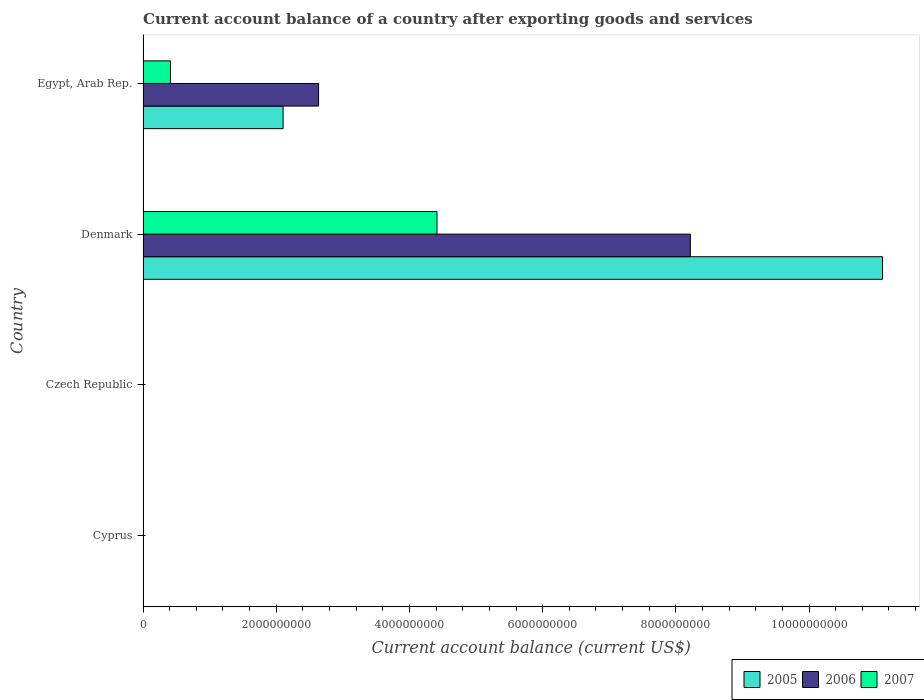How many different coloured bars are there?
Keep it short and to the point. 3. Are the number of bars on each tick of the Y-axis equal?
Your answer should be very brief. No. How many bars are there on the 4th tick from the top?
Give a very brief answer. 0. What is the label of the 4th group of bars from the top?
Your answer should be compact. Cyprus. What is the account balance in 2005 in Egypt, Arab Rep.?
Your answer should be very brief. 2.10e+09. Across all countries, what is the maximum account balance in 2005?
Your answer should be very brief. 1.11e+1. Across all countries, what is the minimum account balance in 2007?
Your answer should be very brief. 0. In which country was the account balance in 2007 maximum?
Make the answer very short. Denmark. What is the total account balance in 2007 in the graph?
Offer a terse response. 4.83e+09. What is the difference between the account balance in 2005 in Denmark and that in Egypt, Arab Rep.?
Give a very brief answer. 9.00e+09. What is the difference between the account balance in 2006 in Czech Republic and the account balance in 2005 in Egypt, Arab Rep.?
Keep it short and to the point. -2.10e+09. What is the average account balance in 2007 per country?
Your response must be concise. 1.21e+09. What is the difference between the account balance in 2005 and account balance in 2007 in Denmark?
Ensure brevity in your answer.  6.69e+09. In how many countries, is the account balance in 2005 greater than 7200000000 US$?
Offer a very short reply. 1. What is the ratio of the account balance in 2006 in Denmark to that in Egypt, Arab Rep.?
Your answer should be very brief. 3.12. What is the difference between the highest and the lowest account balance in 2005?
Your response must be concise. 1.11e+1. Is the sum of the account balance in 2007 in Denmark and Egypt, Arab Rep. greater than the maximum account balance in 2005 across all countries?
Make the answer very short. No. Are all the bars in the graph horizontal?
Make the answer very short. Yes. What is the difference between two consecutive major ticks on the X-axis?
Give a very brief answer. 2.00e+09. Are the values on the major ticks of X-axis written in scientific E-notation?
Give a very brief answer. No. Does the graph contain any zero values?
Make the answer very short. Yes. What is the title of the graph?
Make the answer very short. Current account balance of a country after exporting goods and services. Does "1966" appear as one of the legend labels in the graph?
Keep it short and to the point. No. What is the label or title of the X-axis?
Keep it short and to the point. Current account balance (current US$). What is the Current account balance (current US$) in 2006 in Cyprus?
Give a very brief answer. 0. What is the Current account balance (current US$) of 2007 in Cyprus?
Provide a short and direct response. 0. What is the Current account balance (current US$) in 2005 in Czech Republic?
Provide a short and direct response. 0. What is the Current account balance (current US$) of 2005 in Denmark?
Your answer should be compact. 1.11e+1. What is the Current account balance (current US$) of 2006 in Denmark?
Your answer should be compact. 8.22e+09. What is the Current account balance (current US$) of 2007 in Denmark?
Give a very brief answer. 4.41e+09. What is the Current account balance (current US$) in 2005 in Egypt, Arab Rep.?
Provide a succinct answer. 2.10e+09. What is the Current account balance (current US$) of 2006 in Egypt, Arab Rep.?
Your answer should be compact. 2.64e+09. What is the Current account balance (current US$) in 2007 in Egypt, Arab Rep.?
Offer a very short reply. 4.12e+08. Across all countries, what is the maximum Current account balance (current US$) of 2005?
Your answer should be very brief. 1.11e+1. Across all countries, what is the maximum Current account balance (current US$) in 2006?
Offer a terse response. 8.22e+09. Across all countries, what is the maximum Current account balance (current US$) of 2007?
Keep it short and to the point. 4.41e+09. Across all countries, what is the minimum Current account balance (current US$) of 2006?
Ensure brevity in your answer.  0. Across all countries, what is the minimum Current account balance (current US$) in 2007?
Provide a short and direct response. 0. What is the total Current account balance (current US$) in 2005 in the graph?
Keep it short and to the point. 1.32e+1. What is the total Current account balance (current US$) in 2006 in the graph?
Your response must be concise. 1.09e+1. What is the total Current account balance (current US$) of 2007 in the graph?
Provide a short and direct response. 4.83e+09. What is the difference between the Current account balance (current US$) of 2005 in Denmark and that in Egypt, Arab Rep.?
Keep it short and to the point. 9.00e+09. What is the difference between the Current account balance (current US$) of 2006 in Denmark and that in Egypt, Arab Rep.?
Offer a very short reply. 5.58e+09. What is the difference between the Current account balance (current US$) of 2007 in Denmark and that in Egypt, Arab Rep.?
Your response must be concise. 4.00e+09. What is the difference between the Current account balance (current US$) of 2005 in Denmark and the Current account balance (current US$) of 2006 in Egypt, Arab Rep.?
Give a very brief answer. 8.47e+09. What is the difference between the Current account balance (current US$) in 2005 in Denmark and the Current account balance (current US$) in 2007 in Egypt, Arab Rep.?
Your answer should be compact. 1.07e+1. What is the difference between the Current account balance (current US$) of 2006 in Denmark and the Current account balance (current US$) of 2007 in Egypt, Arab Rep.?
Your answer should be very brief. 7.81e+09. What is the average Current account balance (current US$) in 2005 per country?
Offer a terse response. 3.30e+09. What is the average Current account balance (current US$) in 2006 per country?
Ensure brevity in your answer.  2.71e+09. What is the average Current account balance (current US$) of 2007 per country?
Your answer should be very brief. 1.21e+09. What is the difference between the Current account balance (current US$) of 2005 and Current account balance (current US$) of 2006 in Denmark?
Your answer should be very brief. 2.89e+09. What is the difference between the Current account balance (current US$) in 2005 and Current account balance (current US$) in 2007 in Denmark?
Offer a very short reply. 6.69e+09. What is the difference between the Current account balance (current US$) in 2006 and Current account balance (current US$) in 2007 in Denmark?
Offer a very short reply. 3.80e+09. What is the difference between the Current account balance (current US$) in 2005 and Current account balance (current US$) in 2006 in Egypt, Arab Rep.?
Make the answer very short. -5.33e+08. What is the difference between the Current account balance (current US$) of 2005 and Current account balance (current US$) of 2007 in Egypt, Arab Rep.?
Keep it short and to the point. 1.69e+09. What is the difference between the Current account balance (current US$) of 2006 and Current account balance (current US$) of 2007 in Egypt, Arab Rep.?
Your answer should be compact. 2.22e+09. What is the ratio of the Current account balance (current US$) of 2005 in Denmark to that in Egypt, Arab Rep.?
Your answer should be very brief. 5.28. What is the ratio of the Current account balance (current US$) of 2006 in Denmark to that in Egypt, Arab Rep.?
Offer a very short reply. 3.12. What is the ratio of the Current account balance (current US$) in 2007 in Denmark to that in Egypt, Arab Rep.?
Ensure brevity in your answer.  10.72. What is the difference between the highest and the lowest Current account balance (current US$) of 2005?
Your response must be concise. 1.11e+1. What is the difference between the highest and the lowest Current account balance (current US$) in 2006?
Your answer should be compact. 8.22e+09. What is the difference between the highest and the lowest Current account balance (current US$) of 2007?
Provide a succinct answer. 4.41e+09. 